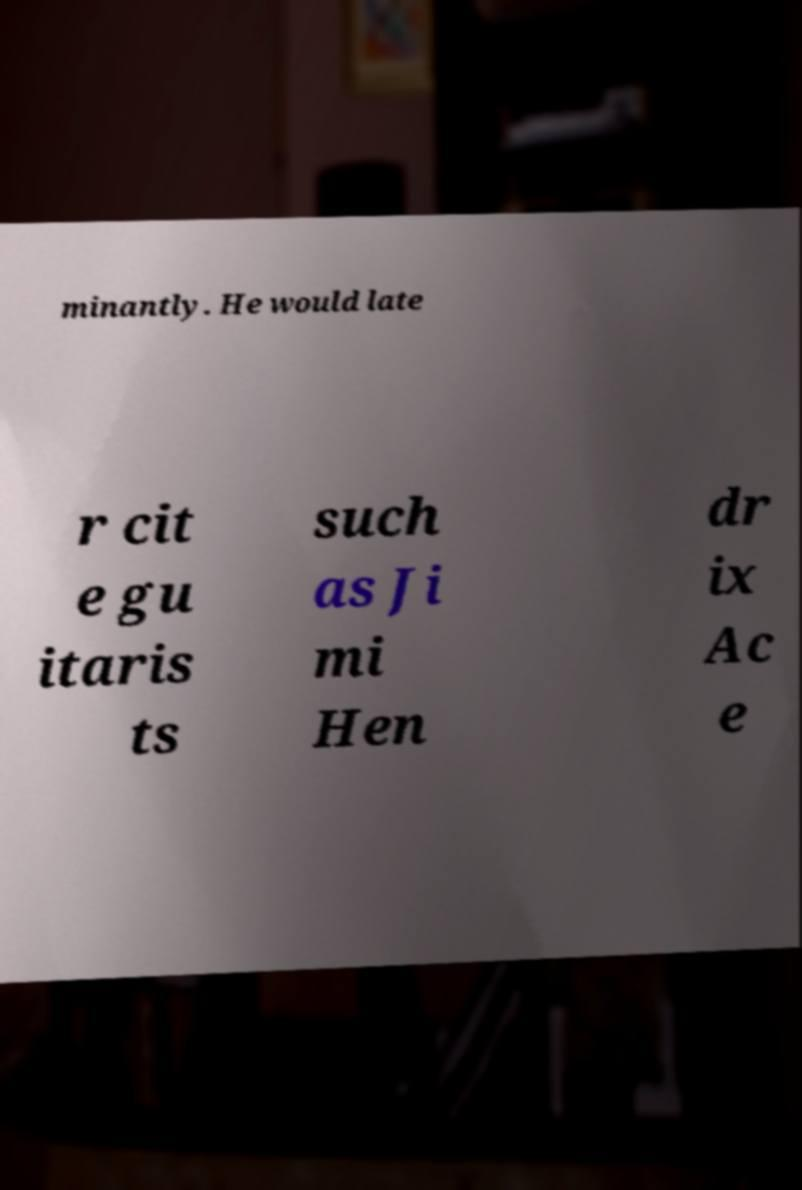Can you accurately transcribe the text from the provided image for me? minantly. He would late r cit e gu itaris ts such as Ji mi Hen dr ix Ac e 